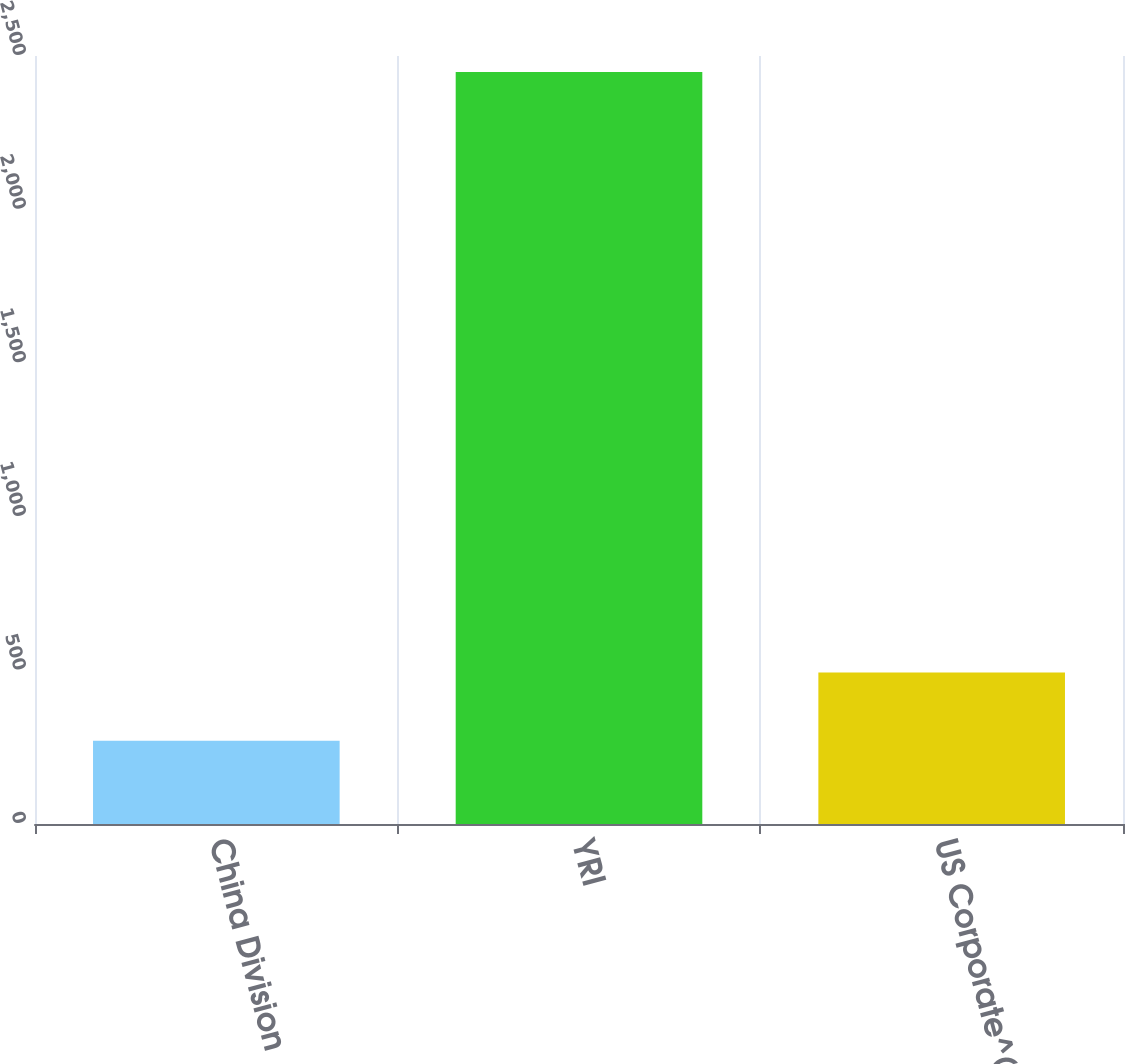Convert chart. <chart><loc_0><loc_0><loc_500><loc_500><bar_chart><fcel>China Division<fcel>YRI<fcel>US Corporate^(i)<nl><fcel>271<fcel>2448<fcel>493<nl></chart> 